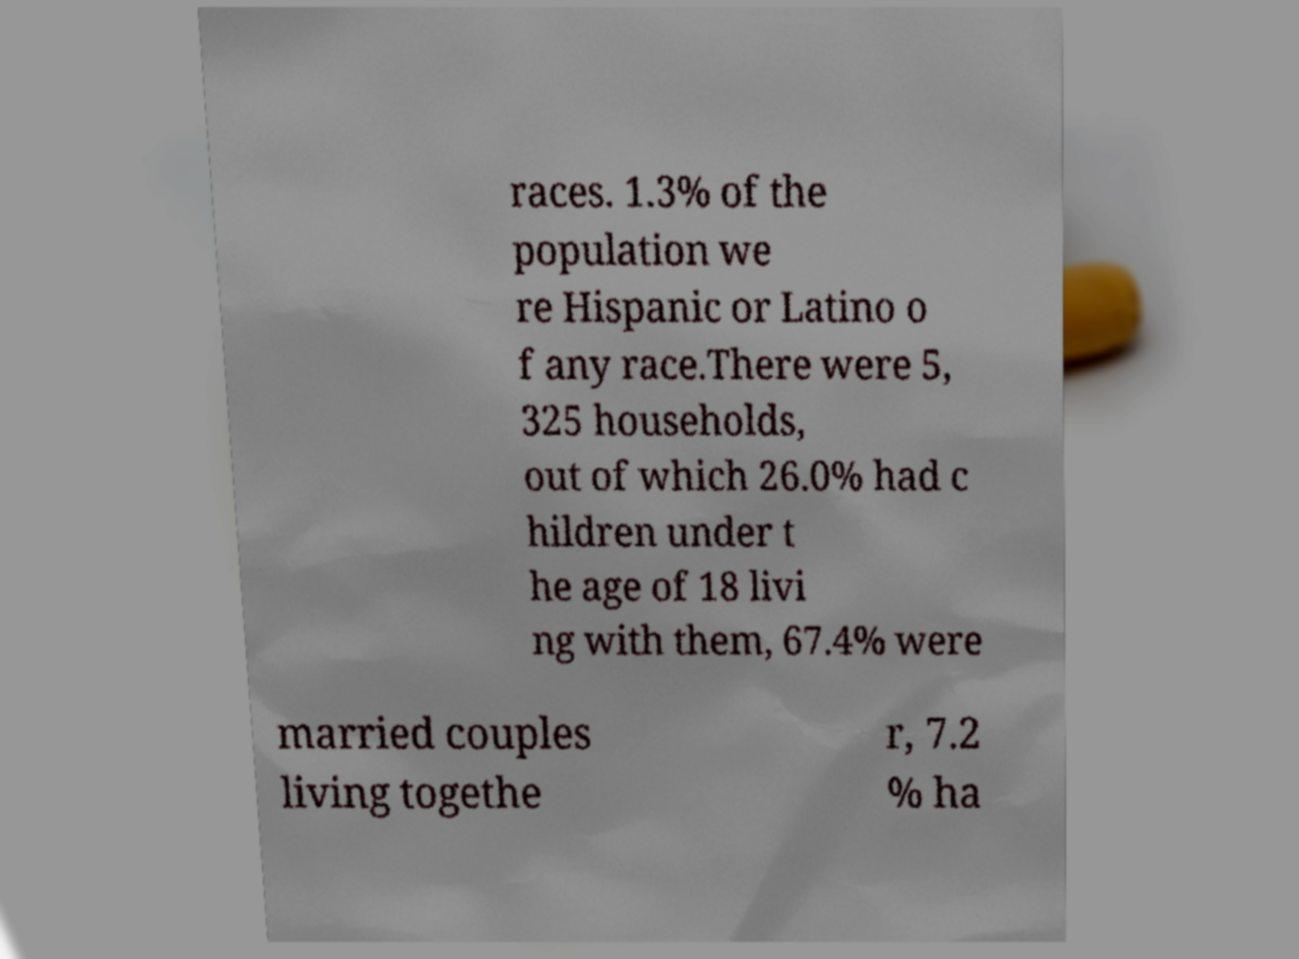I need the written content from this picture converted into text. Can you do that? races. 1.3% of the population we re Hispanic or Latino o f any race.There were 5, 325 households, out of which 26.0% had c hildren under t he age of 18 livi ng with them, 67.4% were married couples living togethe r, 7.2 % ha 